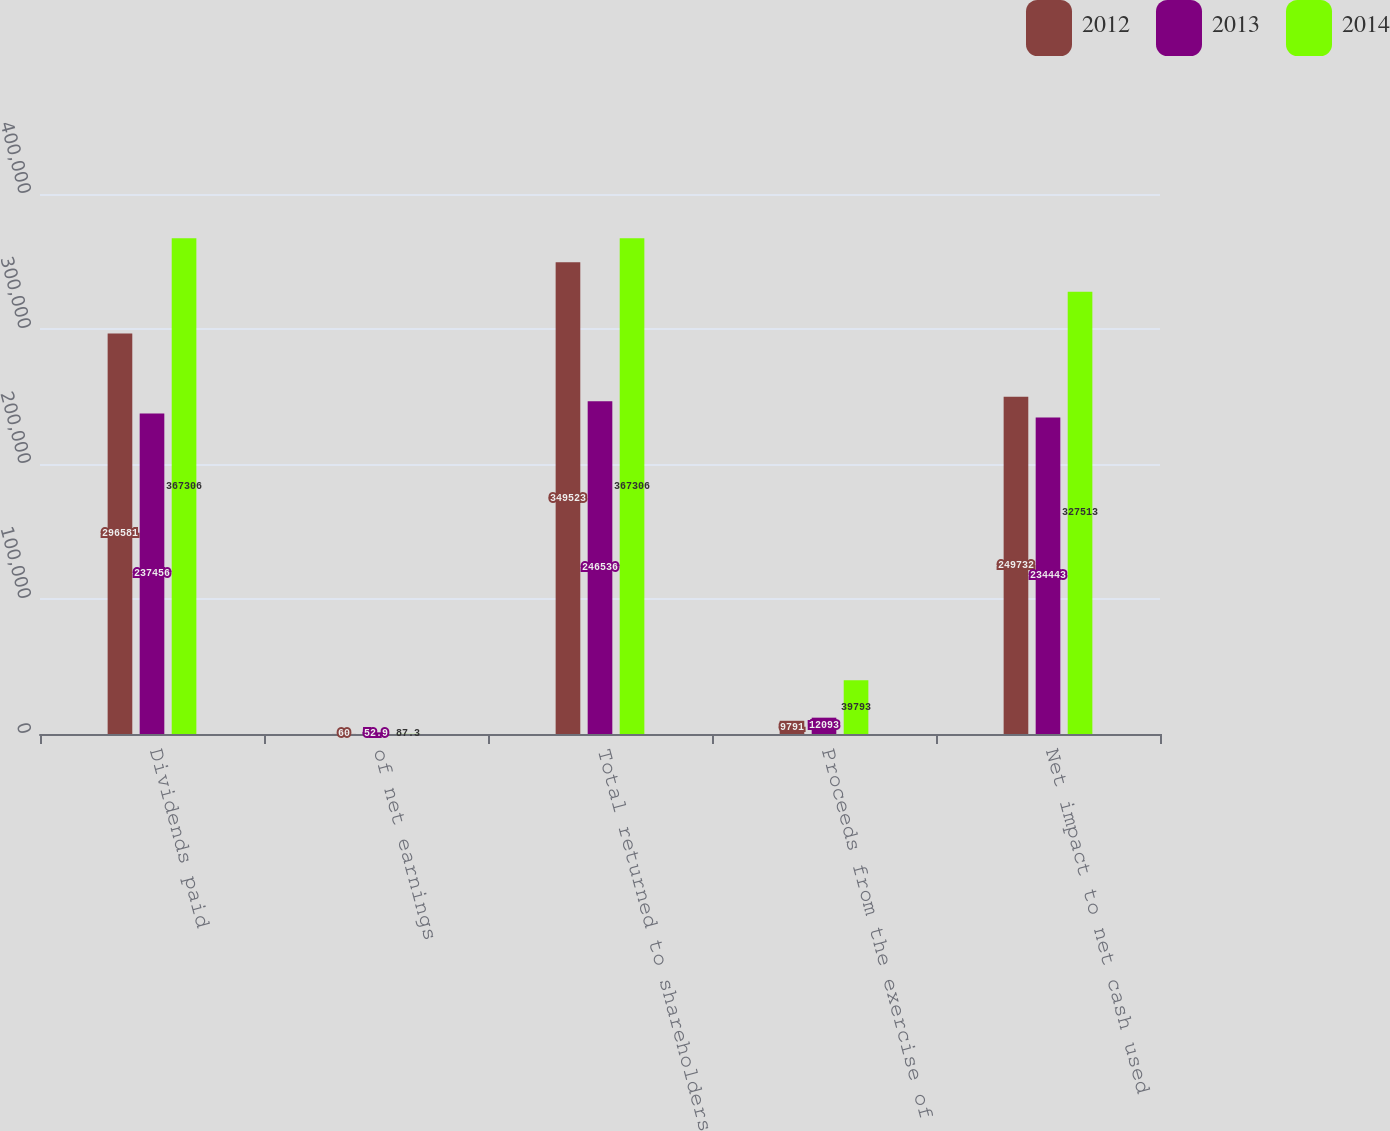Convert chart to OTSL. <chart><loc_0><loc_0><loc_500><loc_500><stacked_bar_chart><ecel><fcel>Dividends paid<fcel>of net earnings<fcel>Total returned to shareholders<fcel>Proceeds from the exercise of<fcel>Net impact to net cash used<nl><fcel>2012<fcel>296581<fcel>60<fcel>349523<fcel>9791<fcel>249732<nl><fcel>2013<fcel>237456<fcel>52.9<fcel>246536<fcel>12093<fcel>234443<nl><fcel>2014<fcel>367306<fcel>87.3<fcel>367306<fcel>39793<fcel>327513<nl></chart> 